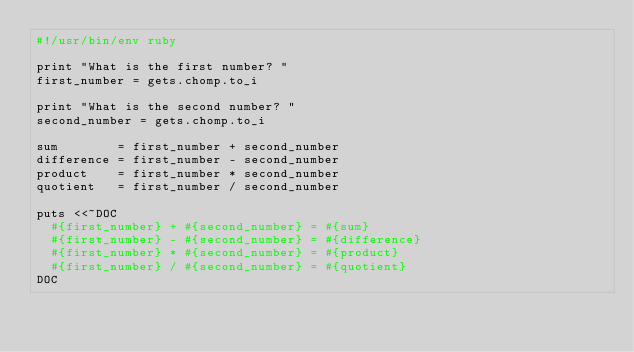<code> <loc_0><loc_0><loc_500><loc_500><_Ruby_>#!/usr/bin/env ruby

print "What is the first number? "
first_number = gets.chomp.to_i

print "What is the second number? "
second_number = gets.chomp.to_i

sum        = first_number + second_number
difference = first_number - second_number
product    = first_number * second_number
quotient   = first_number / second_number

puts <<~DOC
  #{first_number} + #{second_number} = #{sum}
  #{first_number} - #{second_number} = #{difference}
  #{first_number} * #{second_number} = #{product}
  #{first_number} / #{second_number} = #{quotient}
DOC
</code> 